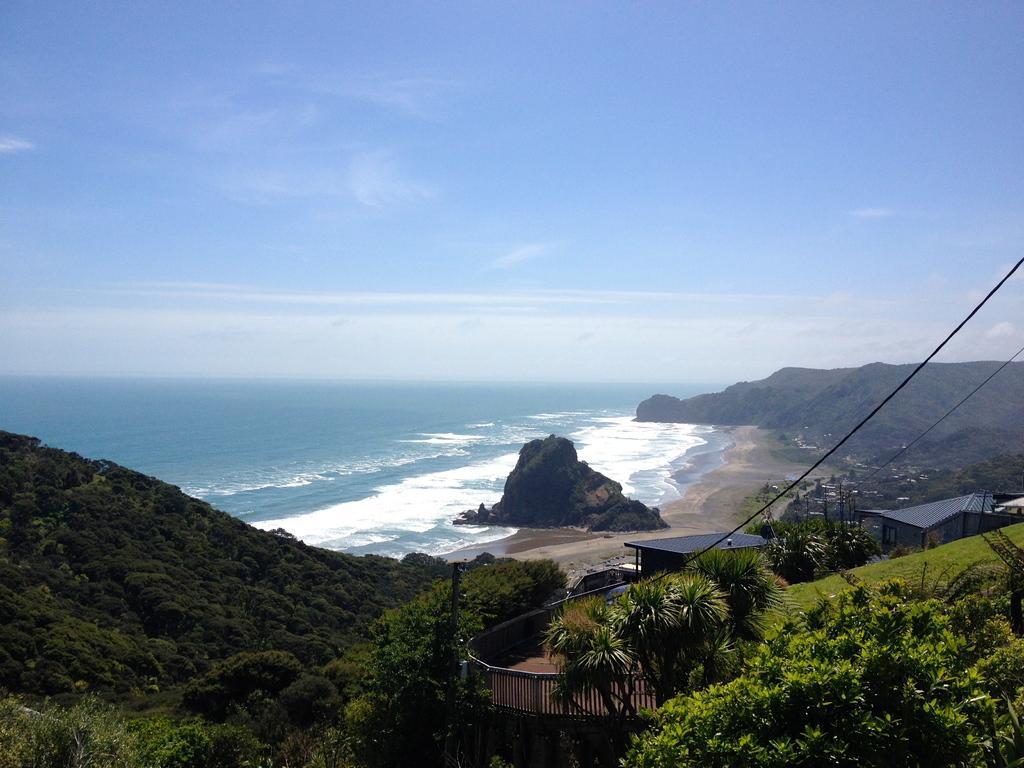What type of natural landform can be seen in the image? There are mountains in the image. What type of vegetation is present in the image? There are trees in the image. What type of man-made structures are visible in the image? There are houses in the image. What can be seen in the background of the image? There is water visible in the background of the image, and the sky is clear. What type of event is taking place in the image? There is no event taking place in the image; it is a static scene featuring mountains, trees, houses, water, and a clear sky. Can you tell me how many pets are visible in the image? There are no pets present in the image. 